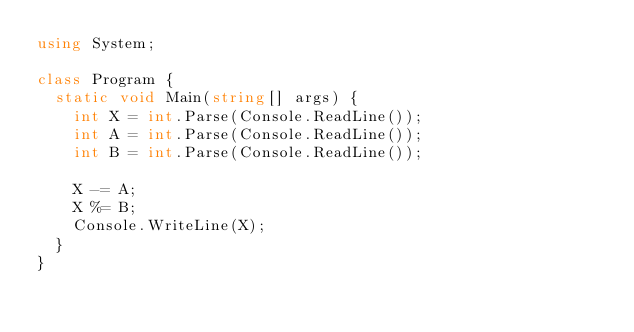Convert code to text. <code><loc_0><loc_0><loc_500><loc_500><_C#_>using System;

class Program {
  static void Main(string[] args) {
    int X = int.Parse(Console.ReadLine());
    int A = int.Parse(Console.ReadLine());
    int B = int.Parse(Console.ReadLine());
    
    X -= A;
    X %= B;
    Console.WriteLine(X);
  }
}
</code> 